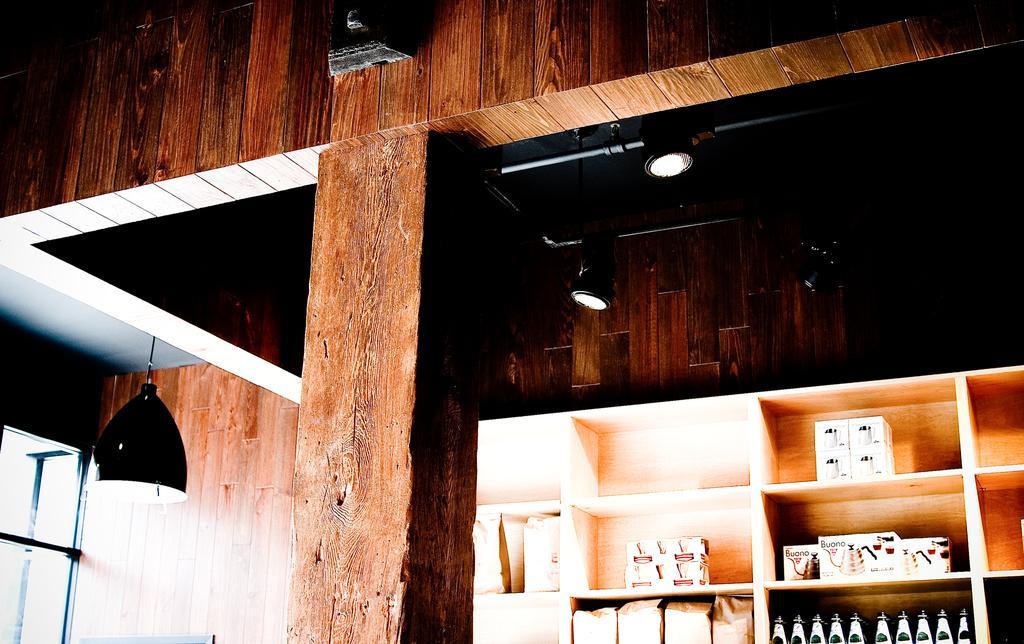Please provide a concise description of this image. In this image there are wooden shelves in the background. In the shelves there are glass bottles,boxes and packets. On the left side there is a light which is hanged to the roof. At the top there are lights. In the middle there is a wooden pillar. 